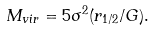Convert formula to latex. <formula><loc_0><loc_0><loc_500><loc_500>M _ { v i r } = 5 \sigma ^ { 2 } ( r _ { 1 / 2 } / G ) .</formula> 